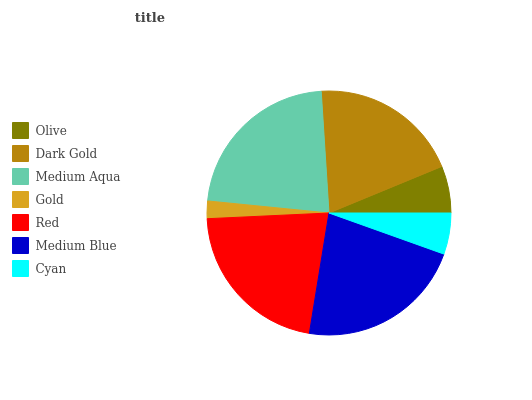Is Gold the minimum?
Answer yes or no. Yes. Is Medium Aqua the maximum?
Answer yes or no. Yes. Is Dark Gold the minimum?
Answer yes or no. No. Is Dark Gold the maximum?
Answer yes or no. No. Is Dark Gold greater than Olive?
Answer yes or no. Yes. Is Olive less than Dark Gold?
Answer yes or no. Yes. Is Olive greater than Dark Gold?
Answer yes or no. No. Is Dark Gold less than Olive?
Answer yes or no. No. Is Dark Gold the high median?
Answer yes or no. Yes. Is Dark Gold the low median?
Answer yes or no. Yes. Is Medium Blue the high median?
Answer yes or no. No. Is Medium Blue the low median?
Answer yes or no. No. 